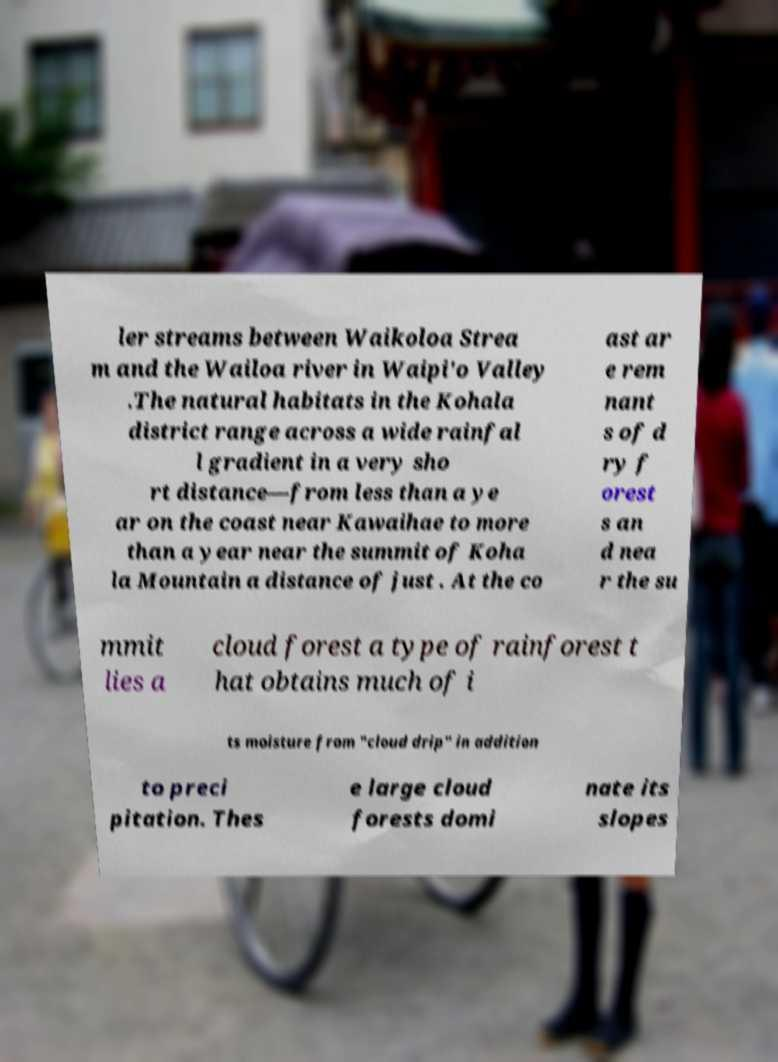Please identify and transcribe the text found in this image. ler streams between Waikoloa Strea m and the Wailoa river in Waipi'o Valley .The natural habitats in the Kohala district range across a wide rainfal l gradient in a very sho rt distance—from less than a ye ar on the coast near Kawaihae to more than a year near the summit of Koha la Mountain a distance of just . At the co ast ar e rem nant s of d ry f orest s an d nea r the su mmit lies a cloud forest a type of rainforest t hat obtains much of i ts moisture from "cloud drip" in addition to preci pitation. Thes e large cloud forests domi nate its slopes 